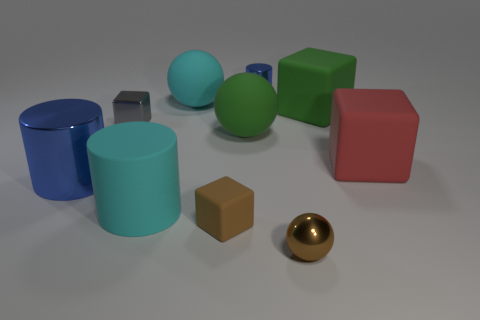Subtract all large balls. How many balls are left? 1 Subtract all red blocks. How many blocks are left? 3 Subtract all yellow cubes. How many blue cylinders are left? 2 Subtract all red balls. Subtract all blue cubes. How many balls are left? 3 Subtract all blocks. How many objects are left? 6 Subtract 0 yellow spheres. How many objects are left? 10 Subtract all small cyan balls. Subtract all blue cylinders. How many objects are left? 8 Add 4 brown metal balls. How many brown metal balls are left? 5 Add 4 cyan cylinders. How many cyan cylinders exist? 5 